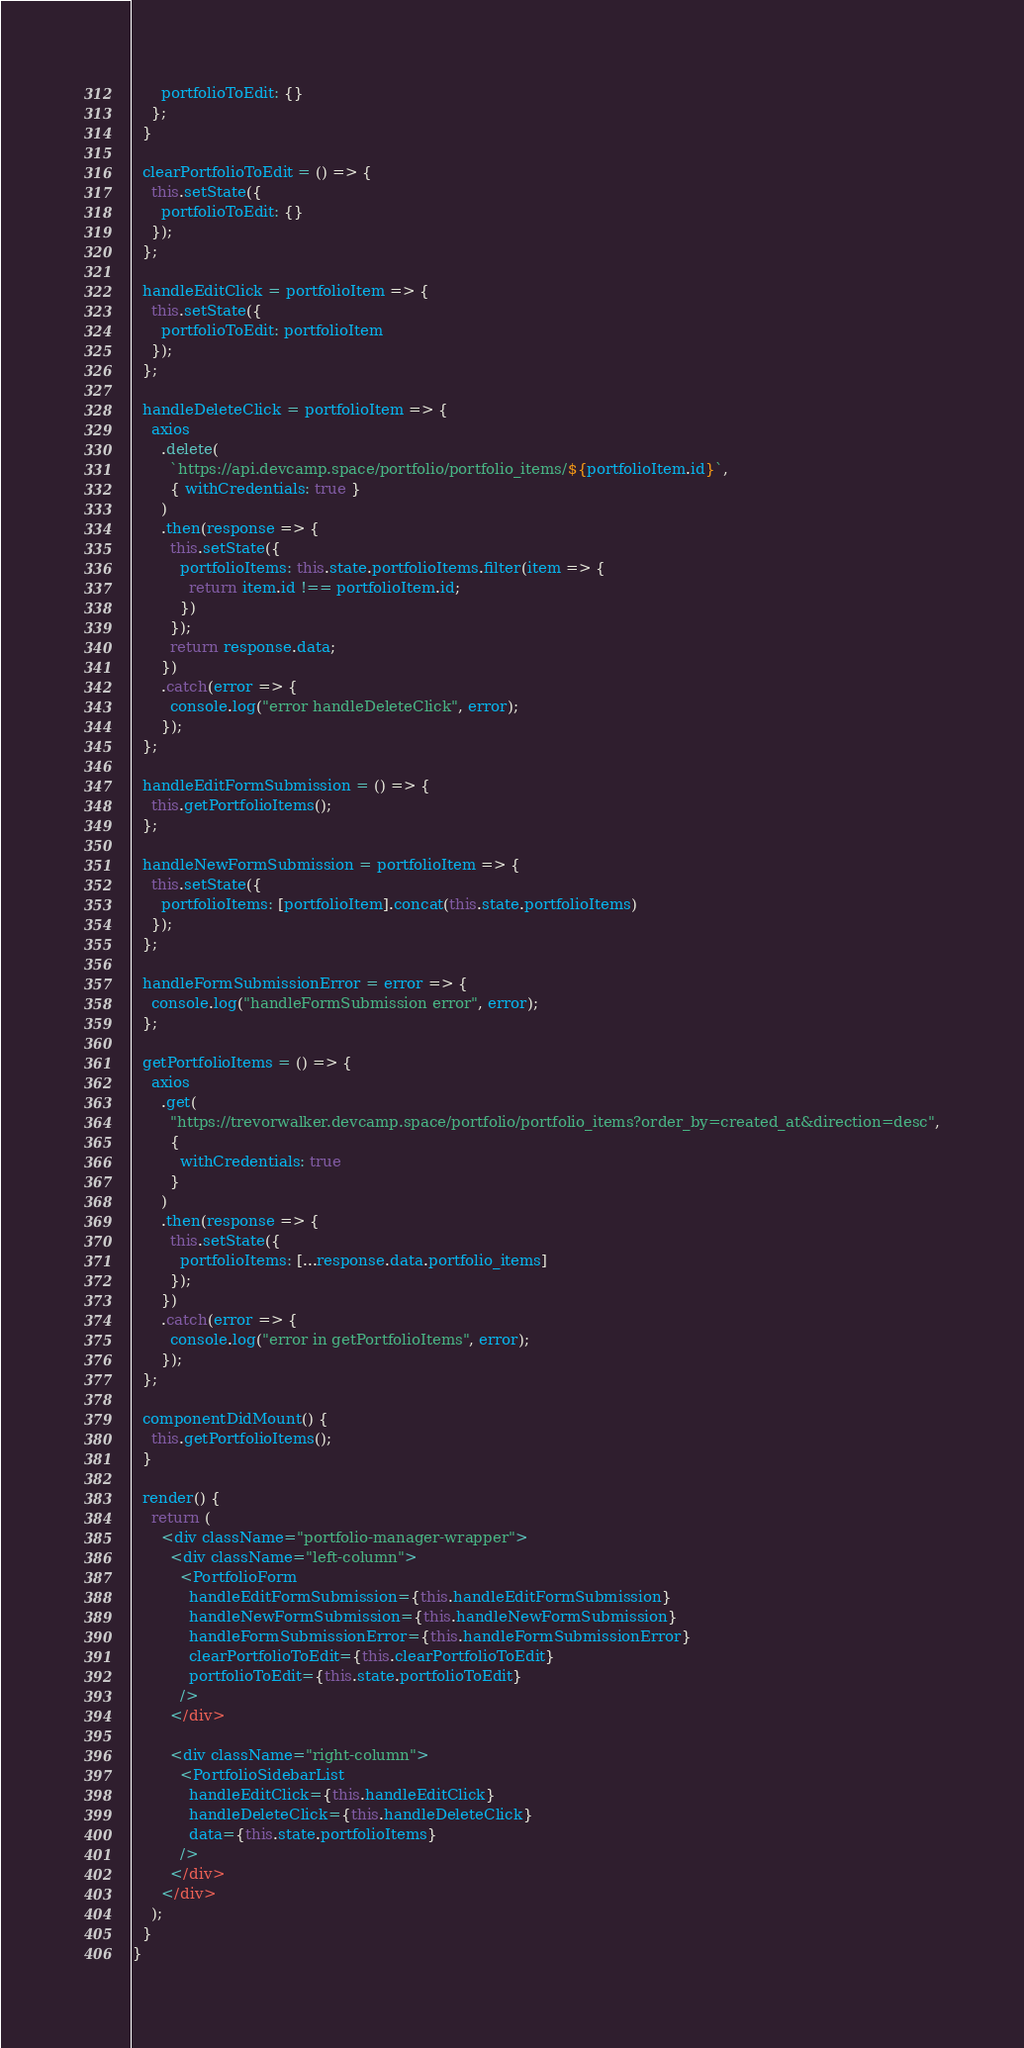<code> <loc_0><loc_0><loc_500><loc_500><_JavaScript_>      portfolioToEdit: {}
    };
  }

  clearPortfolioToEdit = () => {
    this.setState({
      portfolioToEdit: {}
    });
  };

  handleEditClick = portfolioItem => {
    this.setState({
      portfolioToEdit: portfolioItem
    });
  };

  handleDeleteClick = portfolioItem => {
    axios
      .delete(
        `https://api.devcamp.space/portfolio/portfolio_items/${portfolioItem.id}`,
        { withCredentials: true }
      )
      .then(response => {
        this.setState({
          portfolioItems: this.state.portfolioItems.filter(item => {
            return item.id !== portfolioItem.id;
          })
        });
        return response.data;
      })
      .catch(error => {
        console.log("error handleDeleteClick", error);
      });
  };

  handleEditFormSubmission = () => {
    this.getPortfolioItems();
  };

  handleNewFormSubmission = portfolioItem => {
    this.setState({
      portfolioItems: [portfolioItem].concat(this.state.portfolioItems)
    });
  };

  handleFormSubmissionError = error => {
    console.log("handleFormSubmission error", error);
  };

  getPortfolioItems = () => {
    axios
      .get(
        "https://trevorwalker.devcamp.space/portfolio/portfolio_items?order_by=created_at&direction=desc",
        {
          withCredentials: true
        }
      )
      .then(response => {
        this.setState({
          portfolioItems: [...response.data.portfolio_items]
        });
      })
      .catch(error => {
        console.log("error in getPortfolioItems", error);
      });
  };

  componentDidMount() {
    this.getPortfolioItems();
  }

  render() {
    return (
      <div className="portfolio-manager-wrapper">
        <div className="left-column">
          <PortfolioForm
            handleEditFormSubmission={this.handleEditFormSubmission}
            handleNewFormSubmission={this.handleNewFormSubmission}
            handleFormSubmissionError={this.handleFormSubmissionError}
            clearPortfolioToEdit={this.clearPortfolioToEdit}
            portfolioToEdit={this.state.portfolioToEdit}
          />
        </div>

        <div className="right-column">
          <PortfolioSidebarList
            handleEditClick={this.handleEditClick}
            handleDeleteClick={this.handleDeleteClick}
            data={this.state.portfolioItems}
          />
        </div>
      </div>
    );
  }
}
</code> 